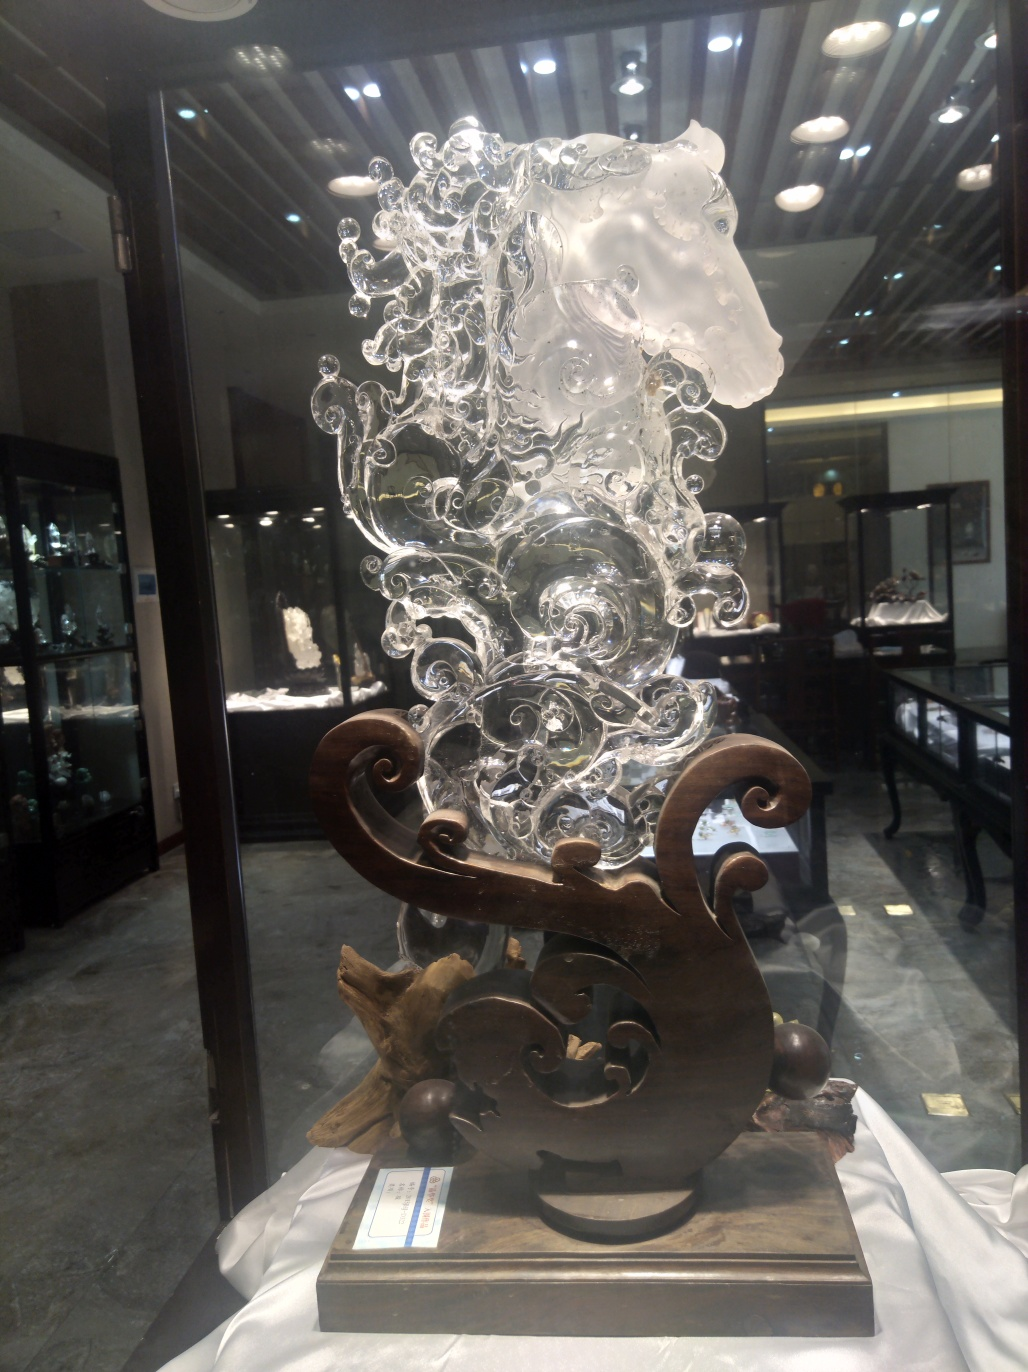Can you explain the significance of the horse motif in this sculpture? The horse in the sculpture symbolizes strength, grace, and freedom, elements often celebrated in various cultures. This motif, intertwined with abstract elements like waves or floral patterns, potentially explores themes of natural force and beauty, suggesting a philosophical or cultural narrative beyond the mere aesthetic. 